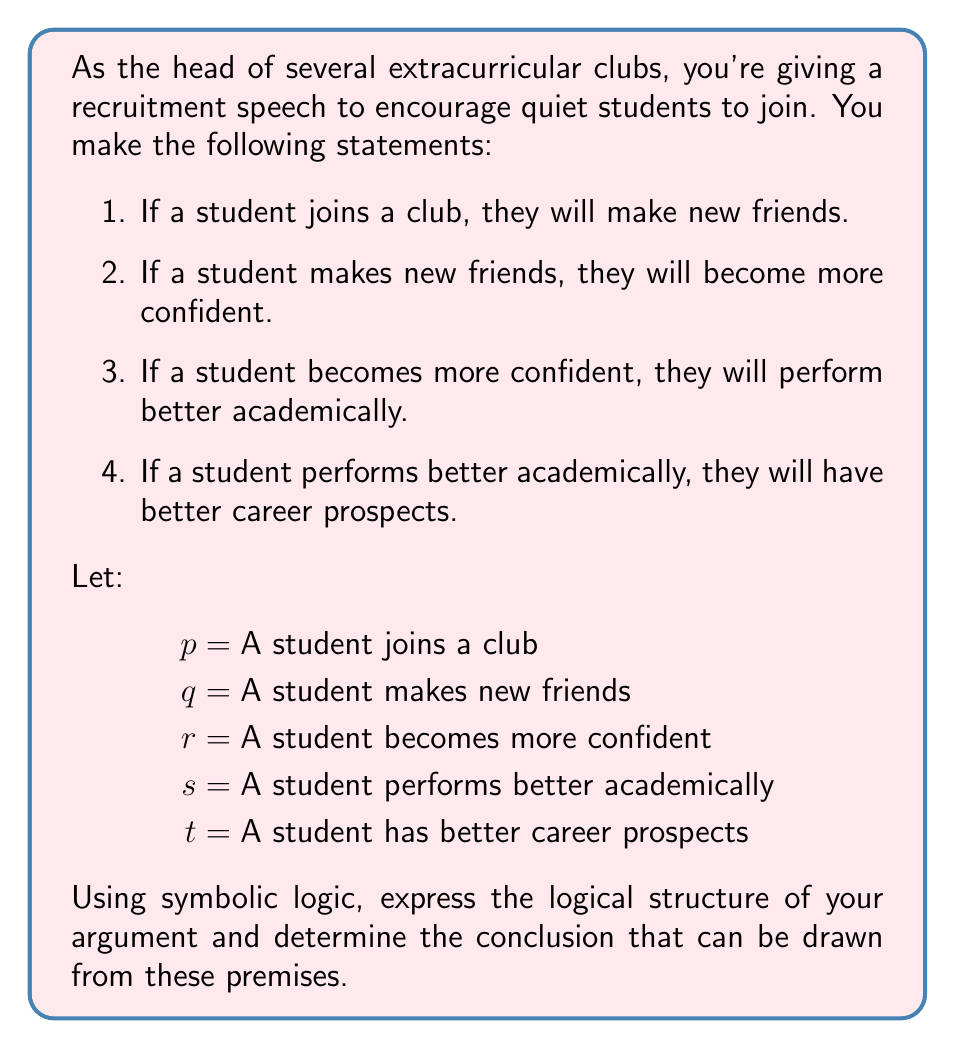Help me with this question. Let's approach this step-by-step:

1. First, we need to express each statement using symbolic logic:

   Statement 1: $p \rightarrow q$
   Statement 2: $q \rightarrow r$
   Statement 3: $r \rightarrow s$
   Statement 4: $s \rightarrow t$

2. Now, we have a chain of implications:

   $p \rightarrow q \rightarrow r \rightarrow s \rightarrow t$

3. In logic, we can use the transitive property of implication, which states that if $A \rightarrow B$ and $B \rightarrow C$, then $A \rightarrow C$.

4. Applying this property to our chain of implications:

   $(p \rightarrow q) \land (q \rightarrow r) \Rightarrow (p \rightarrow r)$
   $(p \rightarrow r) \land (r \rightarrow s) \Rightarrow (p \rightarrow s)$
   $(p \rightarrow s) \land (s \rightarrow t) \Rightarrow (p \rightarrow t)$

5. Therefore, the logical conclusion that can be drawn from these premises is:

   $p \rightarrow t$

This means that if a student joins a club (p), then that student will have better career prospects (t).
Answer: $p \rightarrow t$ (If a student joins a club, then that student will have better career prospects) 